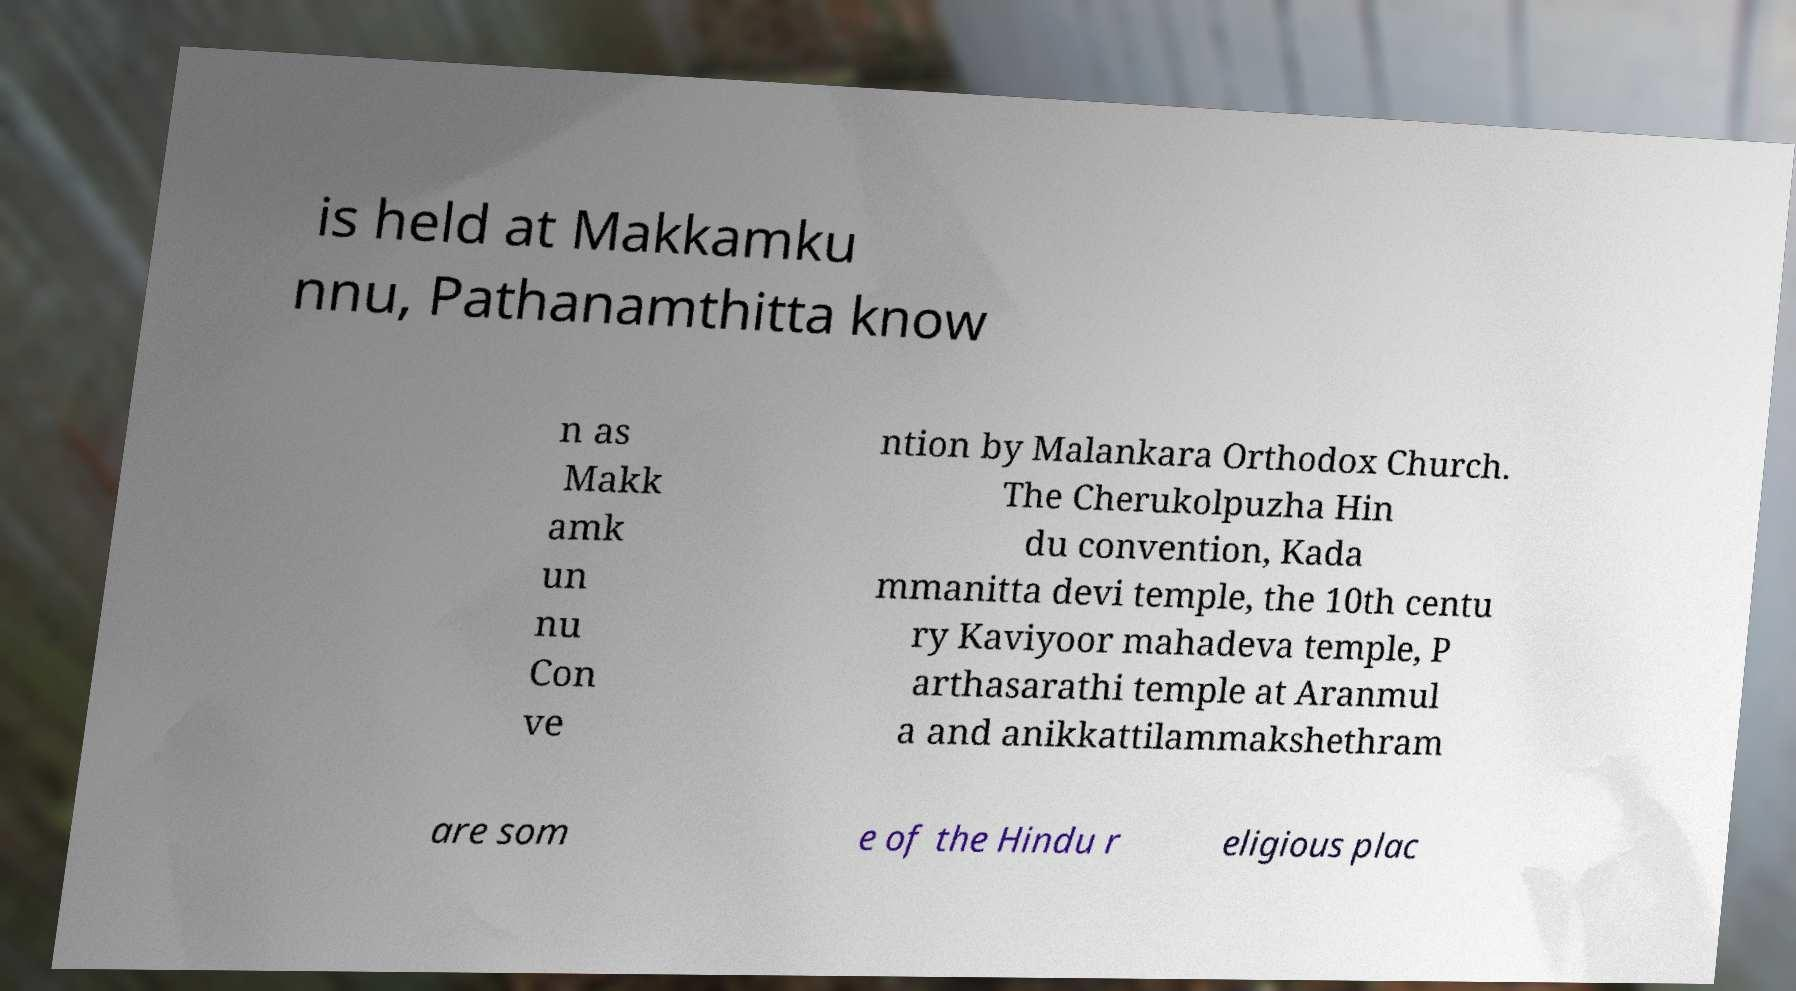I need the written content from this picture converted into text. Can you do that? is held at Makkamku nnu, Pathanamthitta know n as Makk amk un nu Con ve ntion by Malankara Orthodox Church. The Cherukolpuzha Hin du convention, Kada mmanitta devi temple, the 10th centu ry Kaviyoor mahadeva temple, P arthasarathi temple at Aranmul a and anikkattilammakshethram are som e of the Hindu r eligious plac 